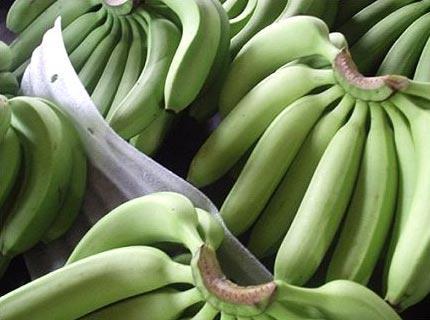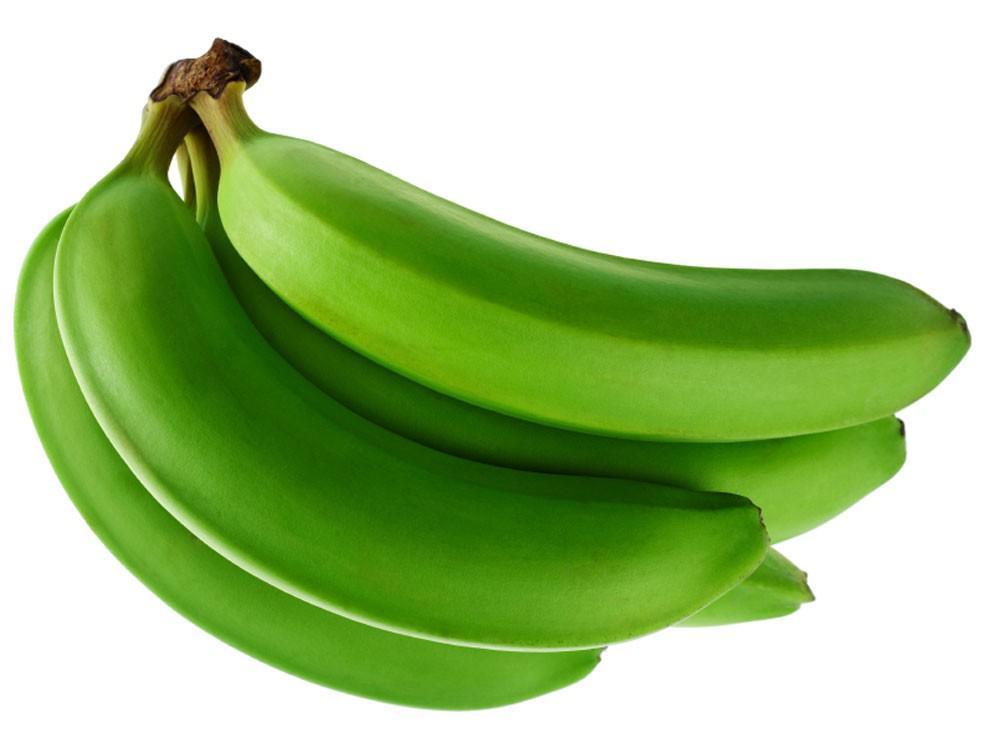The first image is the image on the left, the second image is the image on the right. Considering the images on both sides, is "One image contains three or less plantains, the other contains more than six bananas." valid? Answer yes or no. No. 